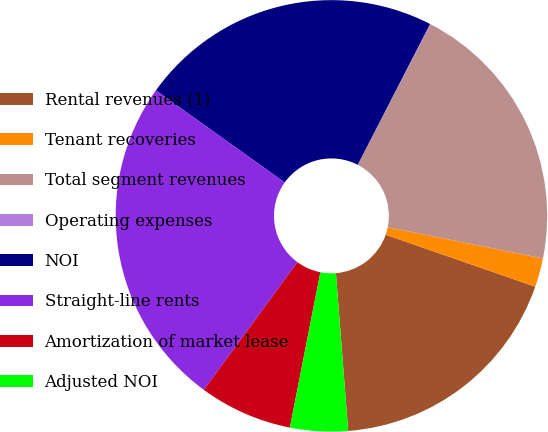Convert chart. <chart><loc_0><loc_0><loc_500><loc_500><pie_chart><fcel>Rental revenues (1)<fcel>Tenant recoveries<fcel>Total segment revenues<fcel>Operating expenses<fcel>NOI<fcel>Straight-line rents<fcel>Amortization of market lease<fcel>Adjusted NOI<nl><fcel>18.44%<fcel>2.16%<fcel>20.56%<fcel>0.04%<fcel>22.68%<fcel>24.8%<fcel>6.99%<fcel>4.32%<nl></chart> 